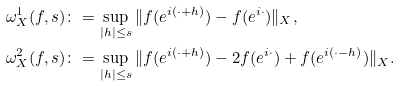Convert formula to latex. <formula><loc_0><loc_0><loc_500><loc_500>\omega _ { X } ^ { 1 } ( f , s ) & \colon = \sup _ { | h | \leq s } \| f ( e ^ { i ( \cdot + h ) } ) - f ( e ^ { i \cdot } ) \| _ { X } , \\ \omega _ { X } ^ { 2 } ( f , s ) & \colon = \sup _ { | h | \leq s } \| f ( e ^ { i ( \cdot + h ) } ) - 2 f ( e ^ { i \cdot } ) + f ( e ^ { i ( \cdot - h ) } ) \| _ { X } .</formula> 